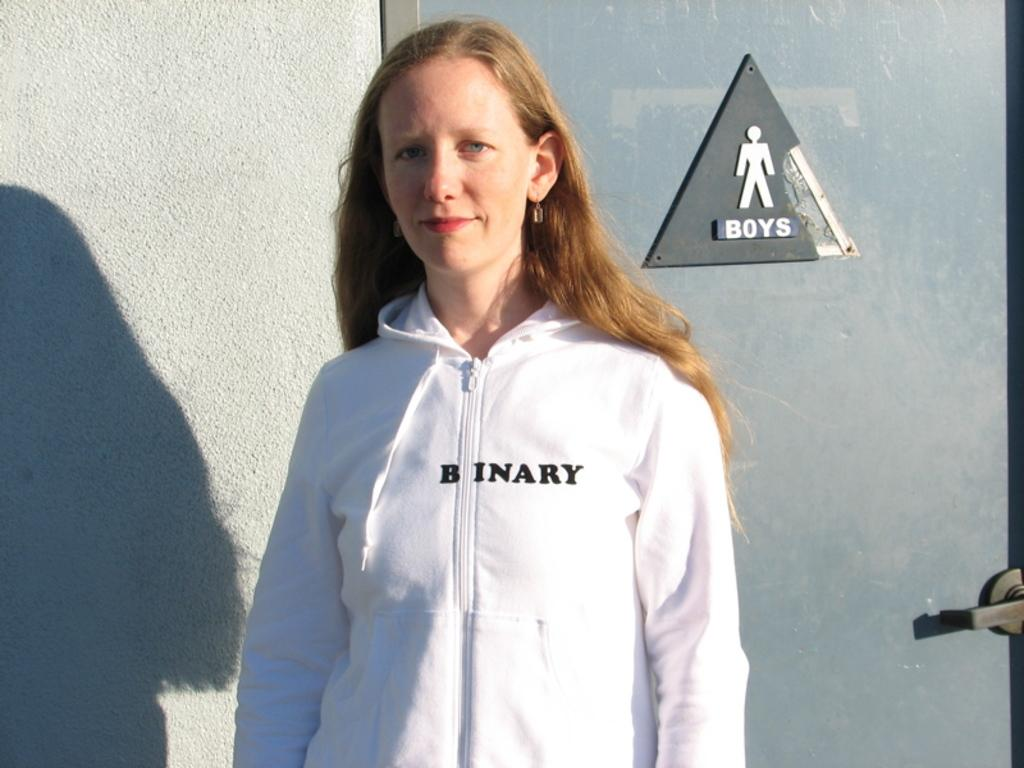<image>
Give a short and clear explanation of the subsequent image. A woman wearing a Binary sweatshirt stand in front of a bathroom. 